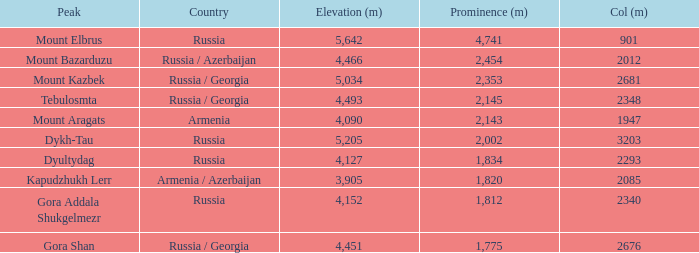When the col (m) of mount kazbek exceeds 2012, what is its prominence (m)? 2353.0. 